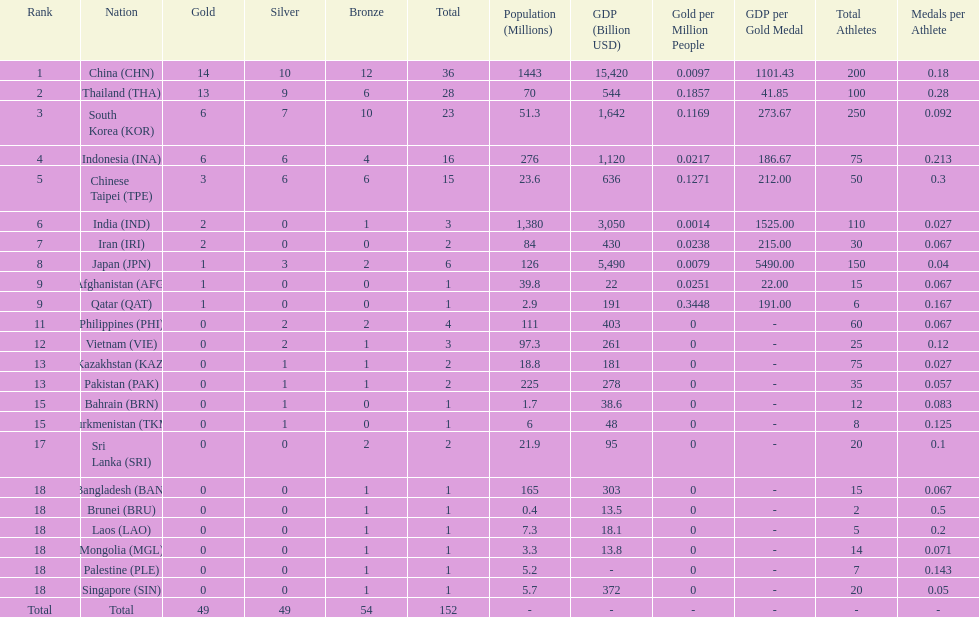How many nations received more than 5 gold medals? 4. 